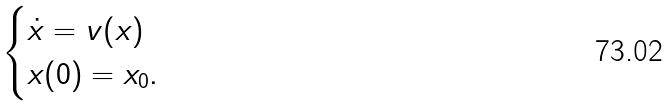<formula> <loc_0><loc_0><loc_500><loc_500>\begin{cases} \dot { x } = v ( x ) \\ x ( 0 ) = x _ { 0 } . \end{cases}</formula> 